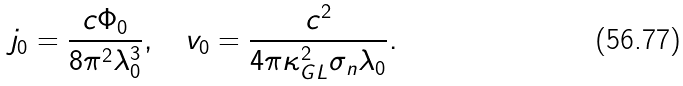Convert formula to latex. <formula><loc_0><loc_0><loc_500><loc_500>j _ { 0 } = \frac { c \Phi _ { 0 } } { 8 \pi ^ { 2 } \lambda _ { 0 } ^ { 3 } } , \quad v _ { 0 } = \frac { c ^ { 2 } } { 4 \pi \kappa ^ { 2 } _ { G L } \sigma _ { n } \lambda _ { 0 } } .</formula> 